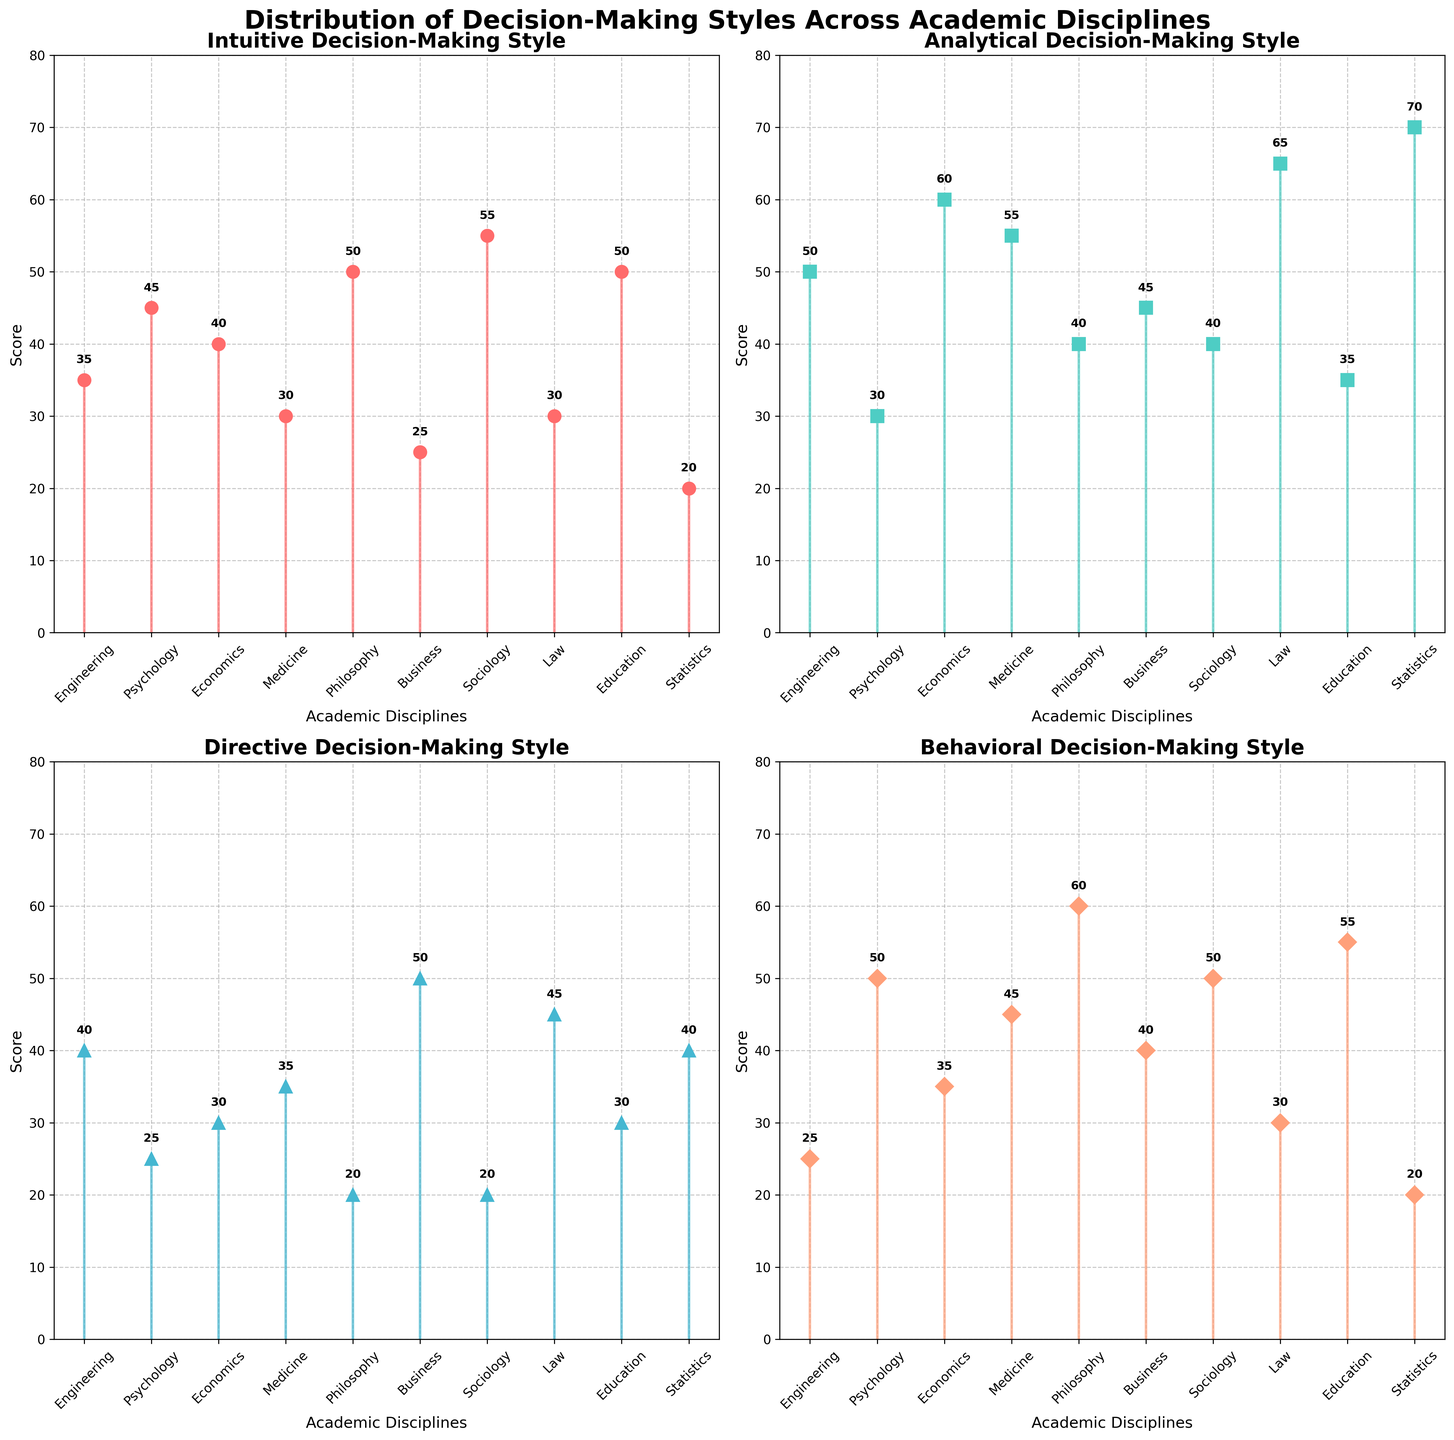What is the title of the figure? The title of the figure is displayed at the top and reads "Distribution of Decision-Making Styles Across Academic Disciplines".
Answer: Distribution of Decision-Making Styles Across Academic Disciplines Which decision-making style has the highest score for Sociology? Look at the subplot titled "Behavioral Decision-Making Style". The score for Sociology is marked as 50.
Answer: Behavioral What is the range of scores for the Analytical decision-making style? In the Analytical decision-making style subplot, the scores range from a minimum of 30 (Psychology) to a maximum of 70 (Statistics). This range is calculated as 70 - 30.
Answer: 40 In which academic discipline do Intuitive and Analytical decision-making styles have exactly equal scores? Compare the Intuitive and Analytical subplots. In Philosophy, both decision-making styles have a score of 50 and 40 respectively, which matches exactly.
Answer: None Which academic discipline shows the highest score in the Directive decision-making style? In the Directive decision-making style subplot, Business has the highest score marked at 50.
Answer: Business What is the average score of the Behavioral decision-making style across all disciplines? Find the Behavioral decision-making scores across all disciplines: 25, 50, 35, 45, 60, 40, 50, 30, 55, 20. Sum these values (25+50+35+45+60+40+50+30+55+20=410) and divide by the number of disciplines (10). The average is 410/10.
Answer: 41 How many disciplines have an Analytical score greater than 50? From the Analytical decision-making subplot, the disciplines with scores greater than 50 are Economics, Medicine, Law, and Statistics. Count these disciplines.
Answer: 4 Which decision-making style shows the most significant variation in scores across all academic disciplines? Compare the range of scores for each decision-making style. The Analytical style shows the most significant variation with scores ranging from 30 to 70.
Answer: Analytical Are there any academic disciplines where Behavioral and Directive decision-making scores are the same? Compare scores for Behavioral and Directive decision-making styles. No discipline has the same score for both styles.
Answer: No What is the difference between the highest and lowest scores in the Intuitive decision-making style? In the Intuitive decision-making style subplot, the highest score is 55 (Sociology) and the lowest score is 20 (Statistics). The difference is 55 - 20.
Answer: 35 